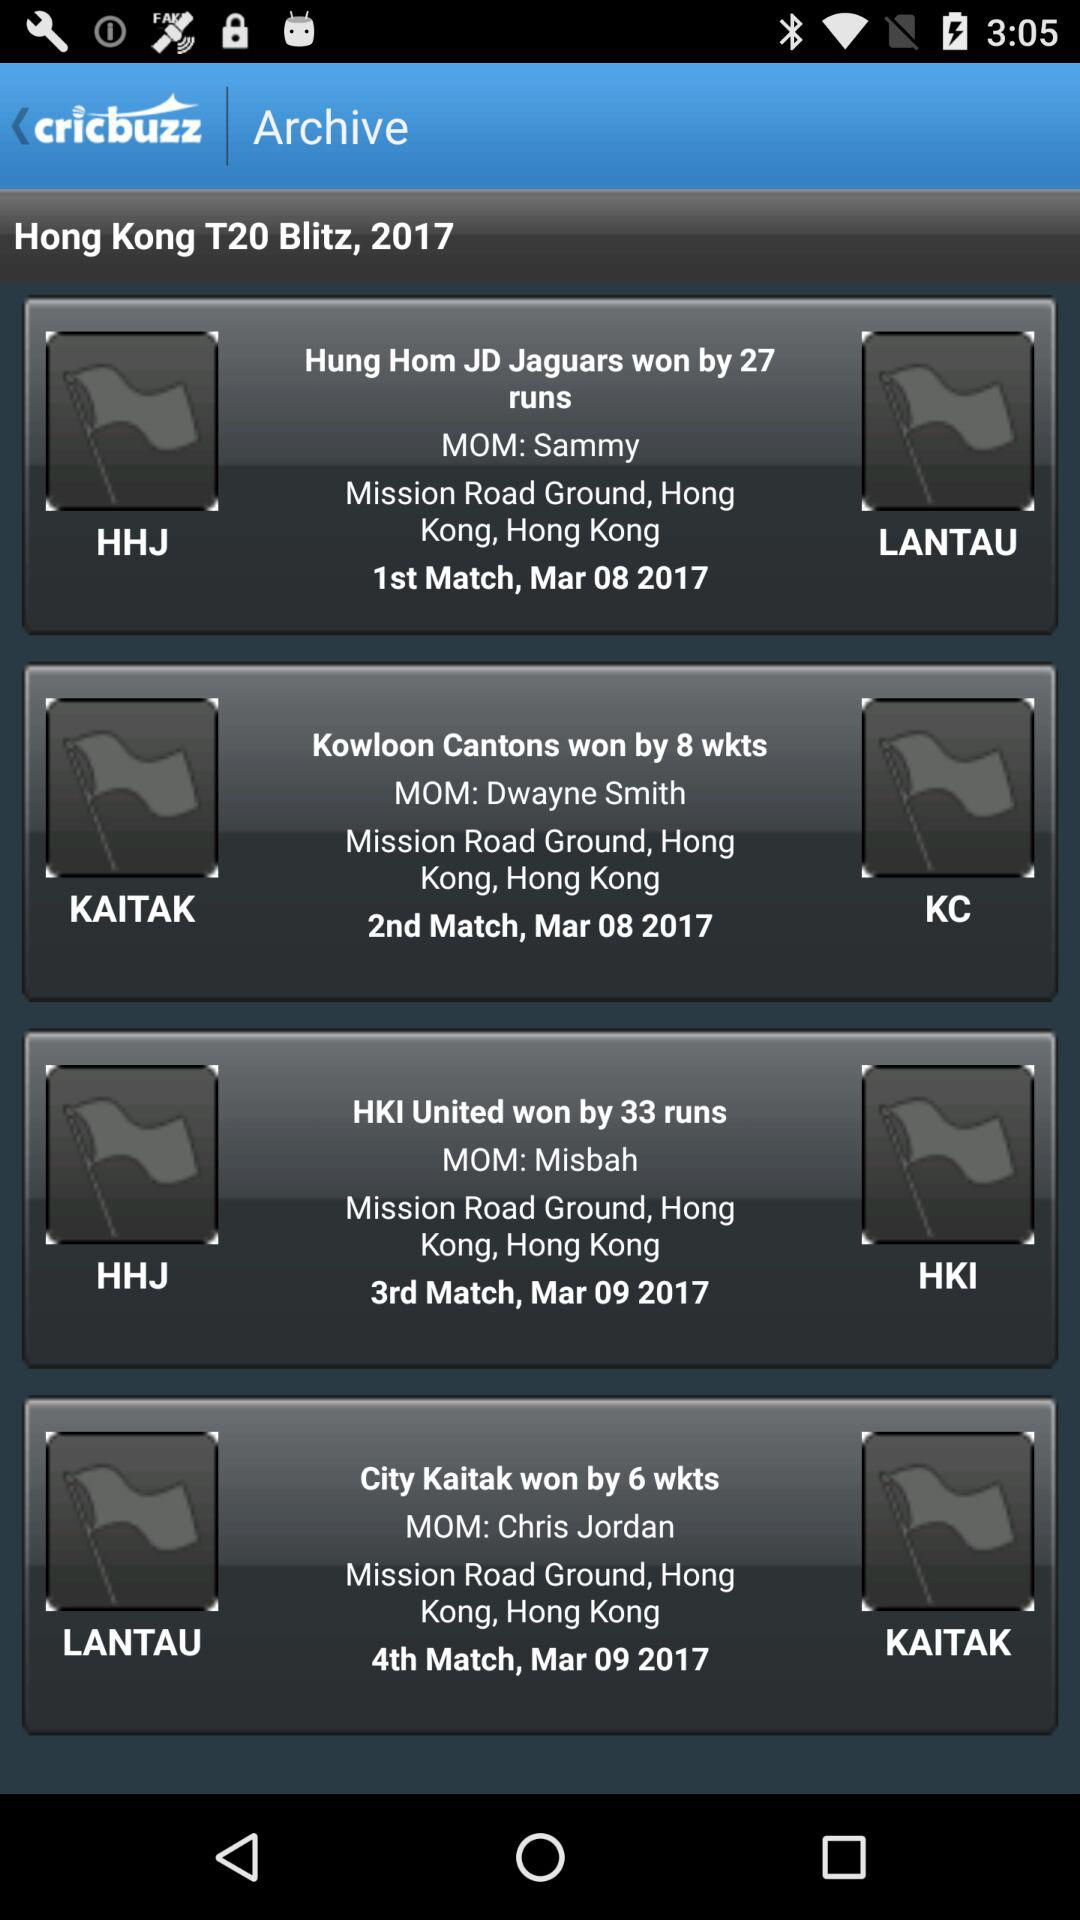What is the date for the City vs. Kai Tak match?
When the provided information is insufficient, respond with <no answer>. <no answer> 